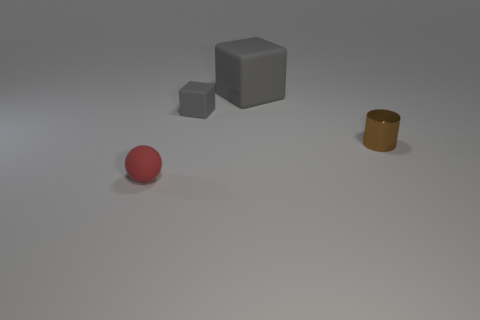Are there any other things that have the same shape as the brown metallic object?
Provide a short and direct response. No. There is a object that is in front of the small block and to the left of the tiny metal cylinder; what is its size?
Offer a terse response. Small. Is the material of the gray object behind the small gray matte object the same as the tiny red sphere?
Ensure brevity in your answer.  Yes. Are there any cyan metal cylinders of the same size as the brown metallic thing?
Provide a short and direct response. No. There is a tiny gray matte thing; is it the same shape as the small object in front of the brown cylinder?
Make the answer very short. No. There is a tiny rubber object to the right of the small sphere that is left of the brown object; are there any objects in front of it?
Ensure brevity in your answer.  Yes. How big is the brown metal thing?
Provide a short and direct response. Small. What number of other objects are the same color as the tiny block?
Offer a very short reply. 1. Does the gray object right of the small gray matte cube have the same shape as the small gray rubber object?
Provide a succinct answer. Yes. What is the color of the large matte object that is the same shape as the small gray thing?
Provide a short and direct response. Gray. 